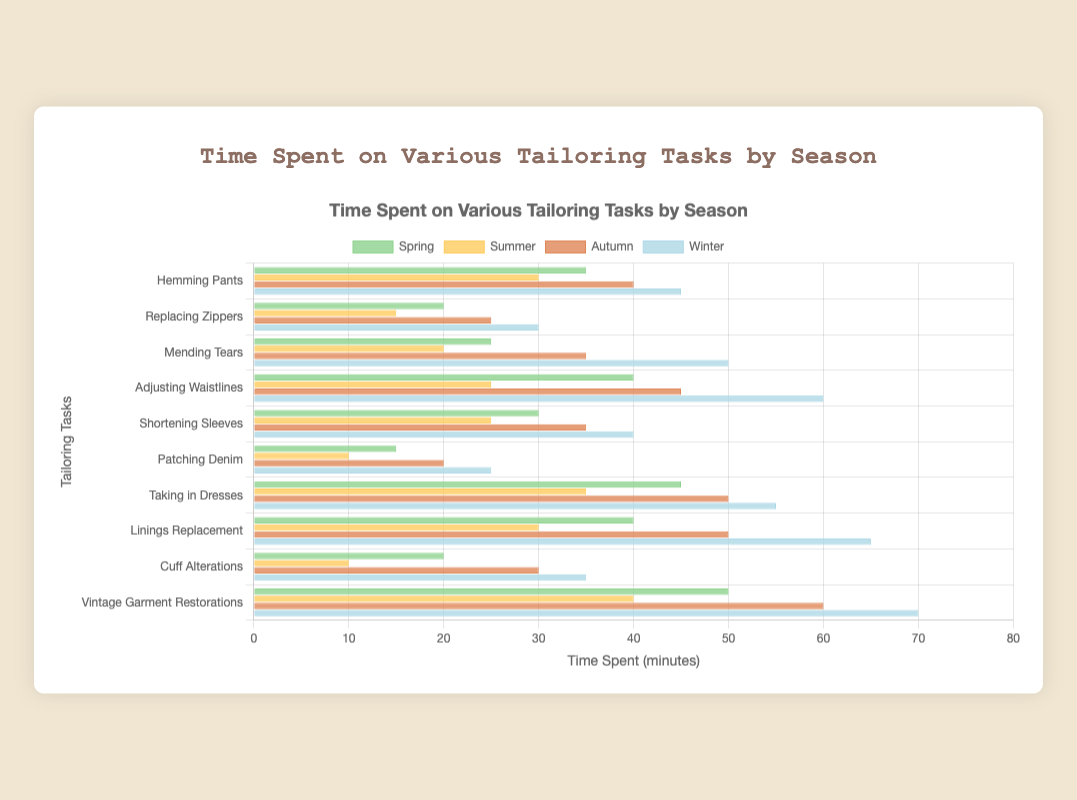Which task takes the most time in Winter? Identify the tallest bar among the tasks in the Winter dataset. "Vintage Garment Restorations" has the tallest bar.
Answer: Vintage Garment Restorations Which season spends the least time on Replacing Zippers? Look for the shortest bar corresponding to "Replacing Zippers." The Summer season bar is the shortest.
Answer: Summer What's the total time spent on Taking in Dresses across all seasons? Add the values for "Taking in Dresses" across all seasons: Spring (45) + Summer (35) + Autumn (50) + Winter (55) = 185
Answer: 185 Which season has the highest average time spent across all tasks? Calculate the average for each season: Spring = (35+20+25+40+30+15+45+40+20+50)/10 = 32, Summer = (30+15+20+25+25+10+35+30+10+40)/10 = 24, Autumn = (40+25+35+45+35+20+50+50+30+60)/10 = 39, Winter = (45+30+50+60+40+25+55+65+35+70)/10 = 47. Winter has the highest average.
Answer: Winter Compare the time spent on Mending Tears in Spring and Winter. Which season spends more and by how much? Subtract the value for Mending Tears in Spring (25) from Winter (50): 50 - 25 = 25. Winter spends more.
Answer: Winter by 25 Which task shows the least variation in time spent across all seasons? Analyze each task's variance or range. "Patching Denim" has the least variation with times of 15, 10, 20, 25. The range is 25-10 = 15.
Answer: Patching Denim In which season does Cuff Alterations take the shortest time? Identify the shortest bar for "Cuff Alterations," which occurs in Summer, with a value of 10 minutes.
Answer: Summer How does the time spent on Adjusting Waistlines in Autumn compare to Spring? Look at the heights of bars for Adjusting Waistlines in Spring and Autumn, which are 40 and 45 respectively. Autumn is higher by 5.
Answer: Autumn by 5 What's the highest time spent on any task in Spring? Identify the tallest bar in the Spring dataset. "Vintage Garment Restorations" is the highest with 50 minutes.
Answer: Vintage Garment Restorations Which task consistently takes the longest time across all seasons? Compare the values for each task across all seasons. "Vintage Garment Restorations" has the highest consistent values across Spring (50), Summer (40), Autumn (60), Winter (70).
Answer: Vintage Garment Restorations 